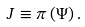<formula> <loc_0><loc_0><loc_500><loc_500>J \equiv \pi \left ( \Psi \right ) .</formula> 